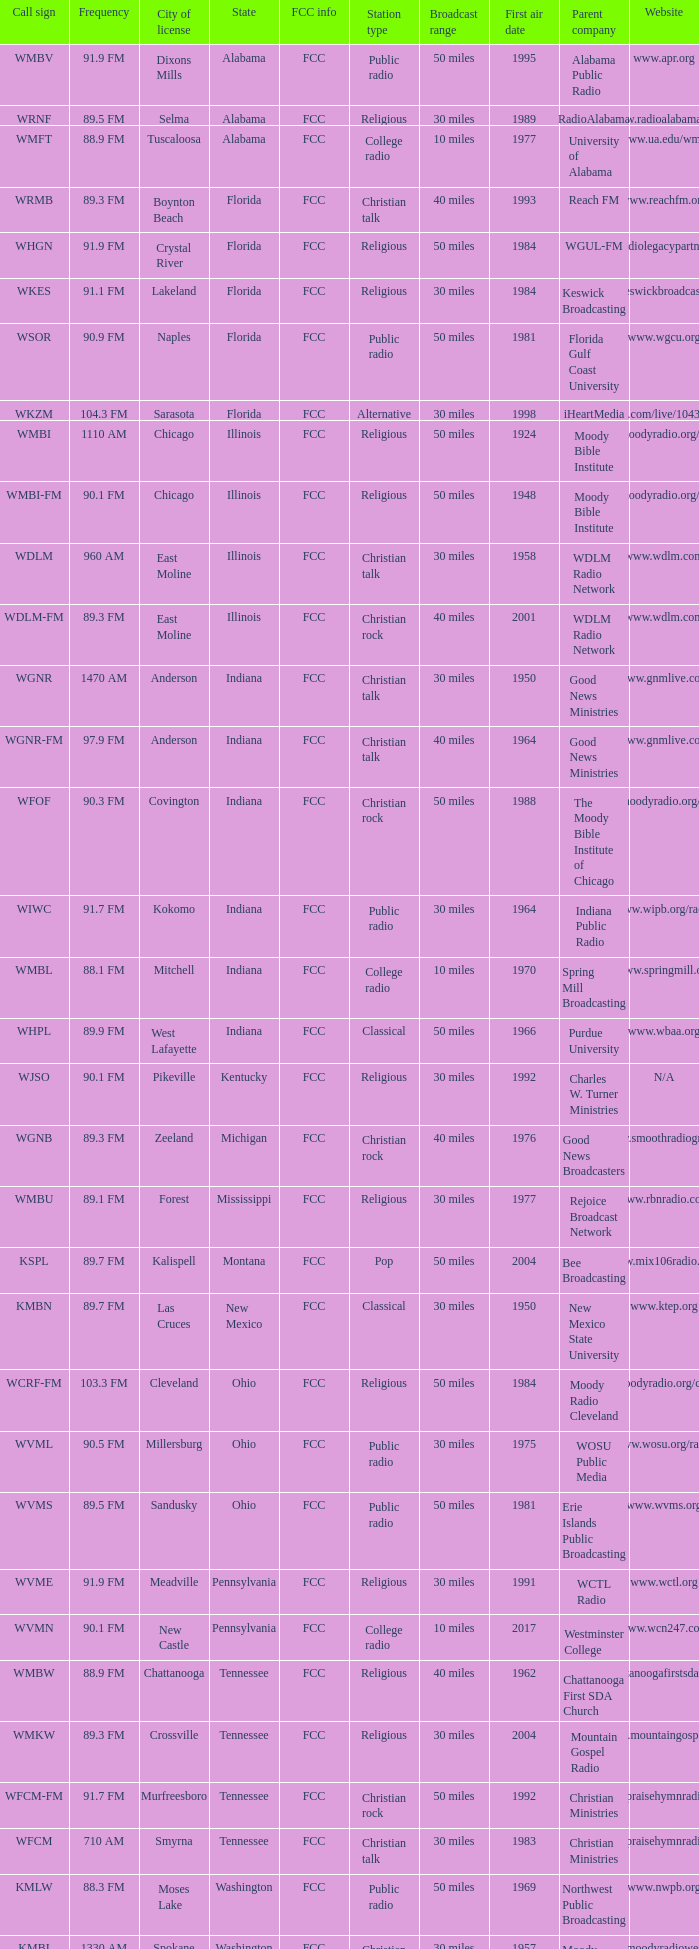What is the FCC info for the radio station in West Lafayette, Indiana? FCC. 